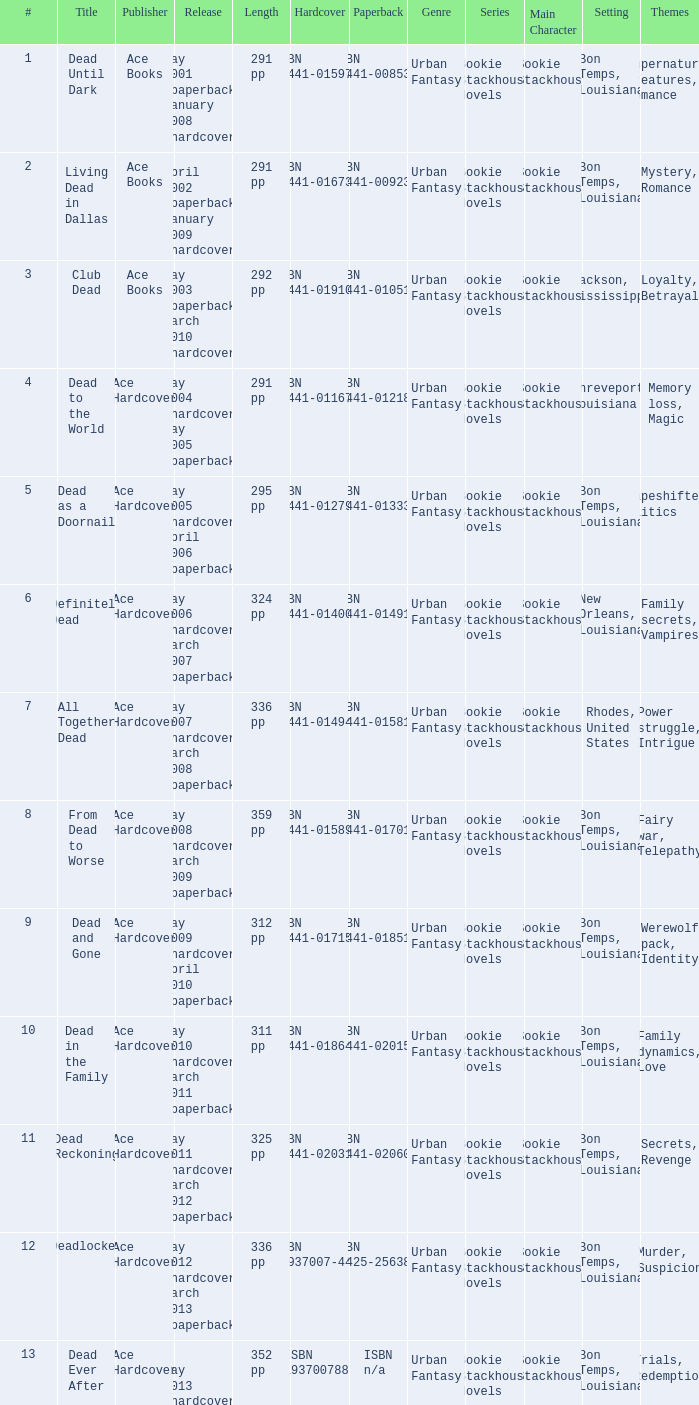Who pubilshed isbn 1-937007-44-8? Ace Hardcover. 